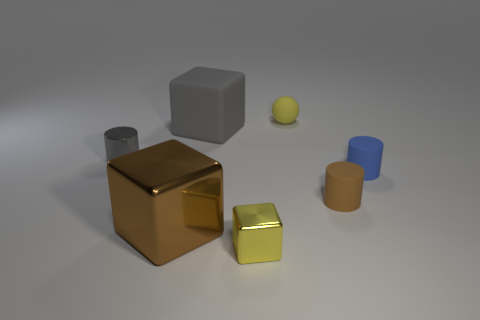Add 1 yellow matte objects. How many objects exist? 8 Subtract all rubber cubes. How many cubes are left? 2 Subtract 2 blocks. How many blocks are left? 1 Subtract all gray cylinders. Subtract all purple cubes. How many cylinders are left? 2 Subtract all brown cylinders. How many brown cubes are left? 1 Subtract all matte blocks. Subtract all small brown rubber objects. How many objects are left? 5 Add 4 gray metal objects. How many gray metal objects are left? 5 Add 5 blue objects. How many blue objects exist? 6 Subtract all gray cylinders. How many cylinders are left? 2 Subtract 0 yellow cylinders. How many objects are left? 7 